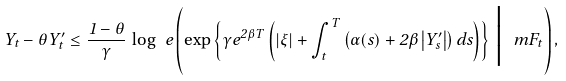<formula> <loc_0><loc_0><loc_500><loc_500>Y _ { t } - \theta Y ^ { \prime } _ { t } \leq \frac { 1 - \theta } { \gamma } \, \log \ e \left ( \exp \left \{ \gamma e ^ { 2 \beta T } \left ( | \xi | + \int _ { t } ^ { T } \left ( \alpha ( s ) + 2 \beta \left | Y ^ { \prime } _ { s } \right | \right ) d s \right ) \right \} \, \Big | \, \ m F _ { t } \right ) ,</formula> 